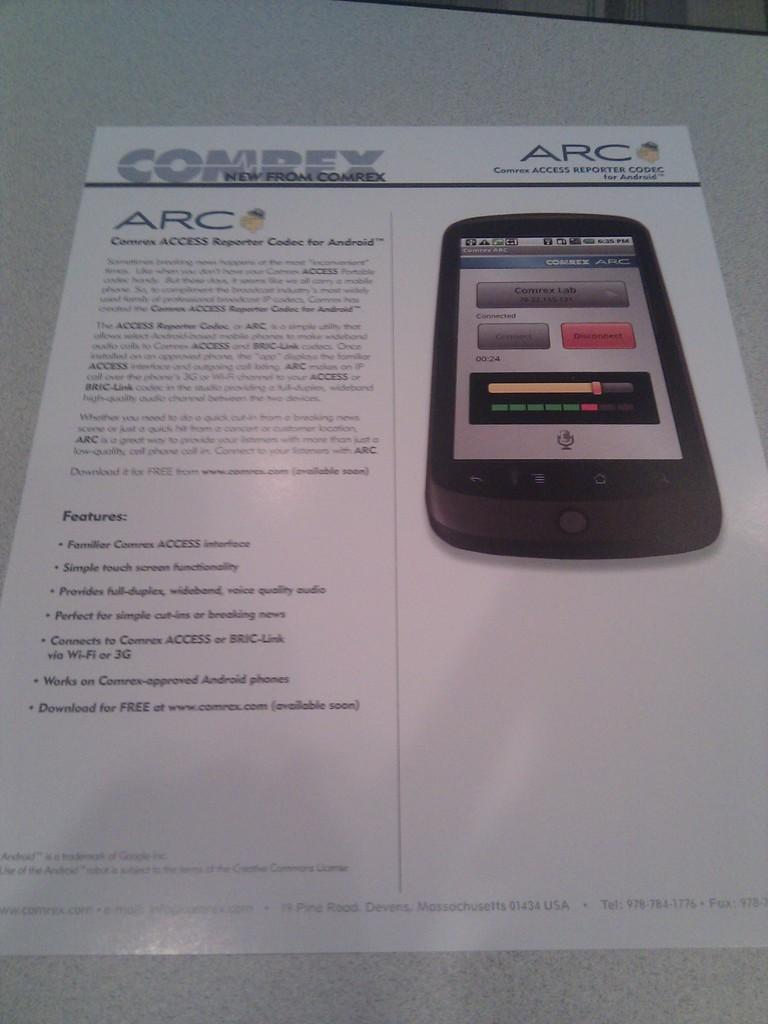Provide a one-sentence caption for the provided image. An advertisement for a phone from the company ARC. 